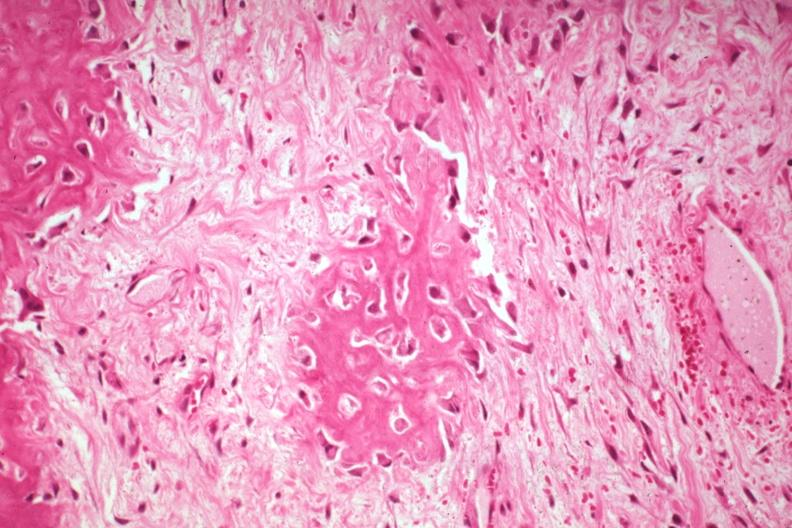s joints present?
Answer the question using a single word or phrase. Yes 